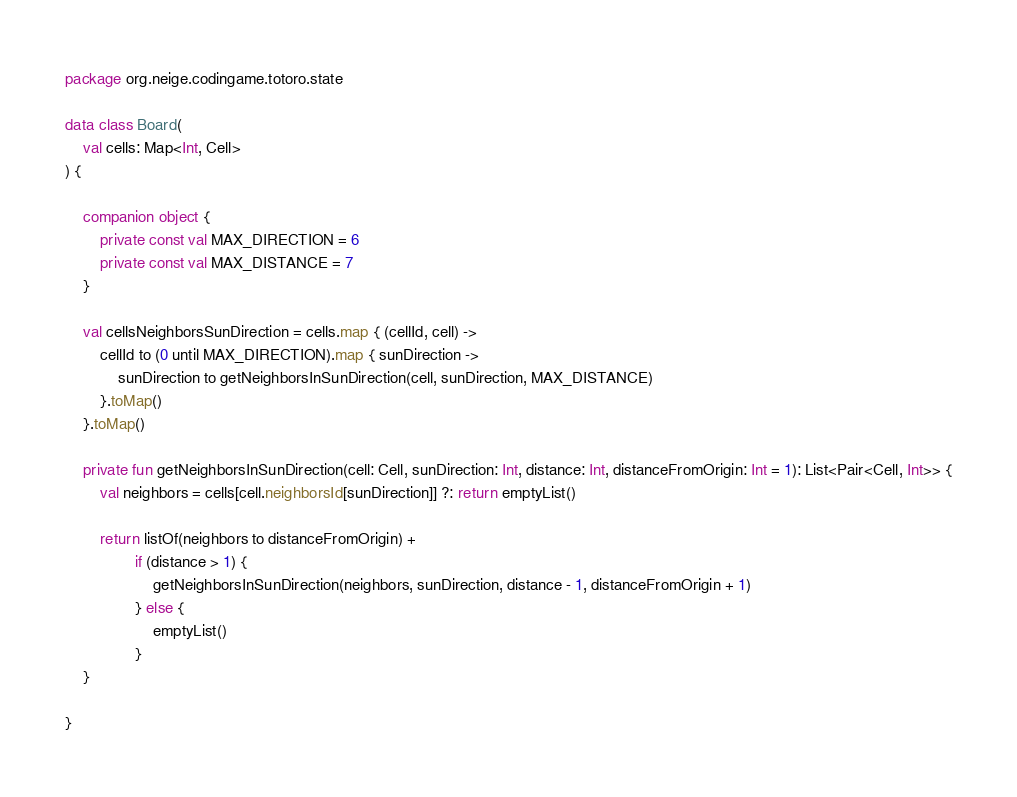Convert code to text. <code><loc_0><loc_0><loc_500><loc_500><_Kotlin_>package org.neige.codingame.totoro.state

data class Board(
    val cells: Map<Int, Cell>
) {

    companion object {
        private const val MAX_DIRECTION = 6
        private const val MAX_DISTANCE = 7
    }

    val cellsNeighborsSunDirection = cells.map { (cellId, cell) ->
        cellId to (0 until MAX_DIRECTION).map { sunDirection ->
            sunDirection to getNeighborsInSunDirection(cell, sunDirection, MAX_DISTANCE)
        }.toMap()
    }.toMap()

    private fun getNeighborsInSunDirection(cell: Cell, sunDirection: Int, distance: Int, distanceFromOrigin: Int = 1): List<Pair<Cell, Int>> {
        val neighbors = cells[cell.neighborsId[sunDirection]] ?: return emptyList()

        return listOf(neighbors to distanceFromOrigin) +
                if (distance > 1) {
                    getNeighborsInSunDirection(neighbors, sunDirection, distance - 1, distanceFromOrigin + 1)
                } else {
                    emptyList()
                }
    }

}
</code> 